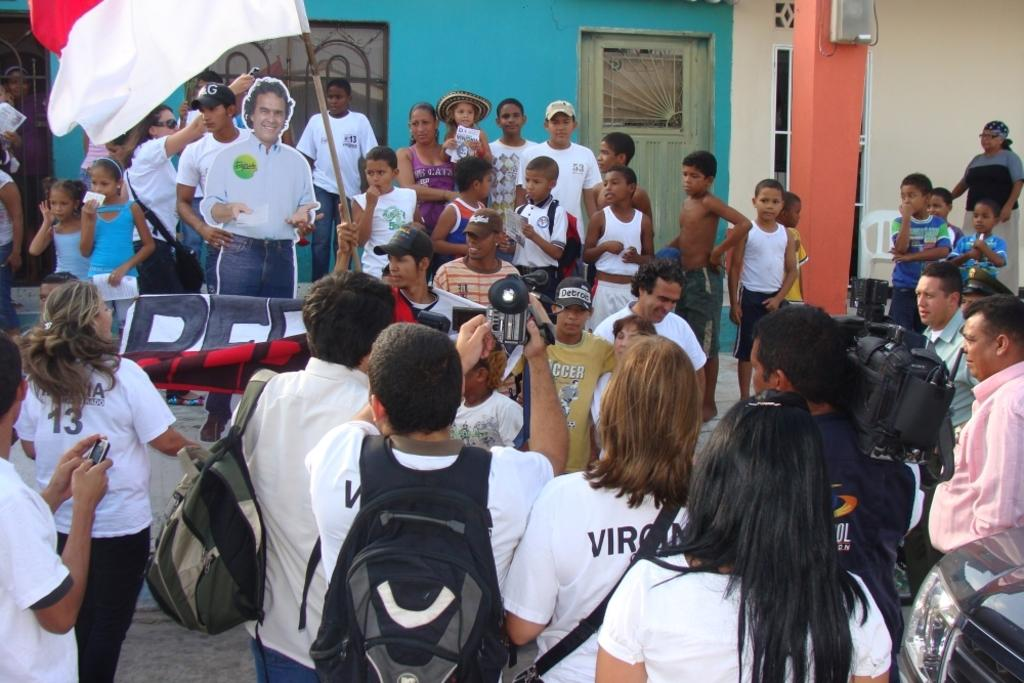What are the people in the image doing? The people in the image are standing and holding a flag and a banner. What can be seen in the hands of the people? The people are holding a flag and a banner. What is visible in the background of the image? There is a poster of a man and a wall in the background. What feature of the wall is mentioned in the facts? There are windows on the wall. What type of pollution is visible in the image? There is no mention of pollution in the image, so it cannot be determined from the facts provided. 